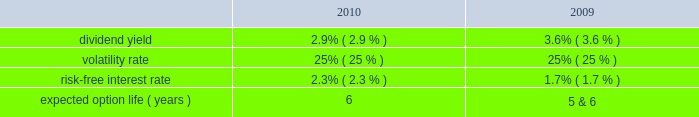Tax benefits recognized for stock-based compensation during the years ended december 31 , 2011 , 2010 and 2009 , were $ 16 million , $ 6 million and $ 5 million , respectively .
The amount of northrop grumman shares issued before the spin-off to satisfy stock-based compensation awards are recorded by northrop grumman and , accordingly , are not reflected in hii 2019s consolidated financial statements .
The company realized tax benefits during the year ended december 31 , 2011 , of $ 2 million from the exercise of stock options and $ 10 million from the issuance of stock in settlement of rpsrs and rsrs .
Unrecognized compensation expense at december 31 , 2011 there was $ 1 million of unrecognized compensation expense related to unvested stock option awards , which will be recognized over a weighted average period of 1.1 years .
In addition , at december 31 , 2011 , there was $ 19 million of unrecognized compensation expense associated with the 2011 rsrs , which will be recognized over a period of 2.2 years ; $ 10 million of unrecognized compensation expense associated with the rpsrs converted as part of the spin-off , which will be recognized over a weighted average period of one year ; and $ 18 million of unrecognized compensation expense associated with the 2011 rpsrs which will be recognized over a period of 2.0 years .
Stock options the compensation expense for the outstanding converted stock options was determined at the time of grant by northrop grumman .
There were no additional options granted during the year ended december 31 , 2011 .
The fair value of the stock option awards is expensed on a straight-line basis over the vesting period of the options .
The fair value of each of the stock option award was estimated on the date of grant using a black-scholes option pricing model based on the following assumptions : dividend yield 2014the dividend yield was based on northrop grumman 2019s historical dividend yield level .
Volatility 2014expected volatility was based on the average of the implied volatility from traded options and the historical volatility of northrop grumman 2019s stock .
Risk-free interest rate 2014the risk-free rate for periods within the contractual life of the stock option award was based on the yield curve of a zero-coupon u.s .
Treasury bond on the date the award was granted with a maturity equal to the expected term of the award .
Expected term 2014the expected term of awards granted was derived from historical experience and represents the period of time that awards granted are expected to be outstanding .
A stratification of expected terms based on employee populations ( executive and non-executive ) was considered in the analysis .
The following significant weighted-average assumptions were used to value stock options granted during the years ended december 31 , 2010 and 2009: .
The weighted-average grant date fair value of stock options granted during the years ended december 31 , 2010 and 2009 , was $ 11 and $ 7 , per share , respectively. .
What was the percentage decline in the dividend yield from 2009 to 2010? 
Rationale: the percentage change is the difference between the current and most recent divided by the most recent
Computations: ((2.9 - 3.6) / 3.6)
Answer: -0.19444. 